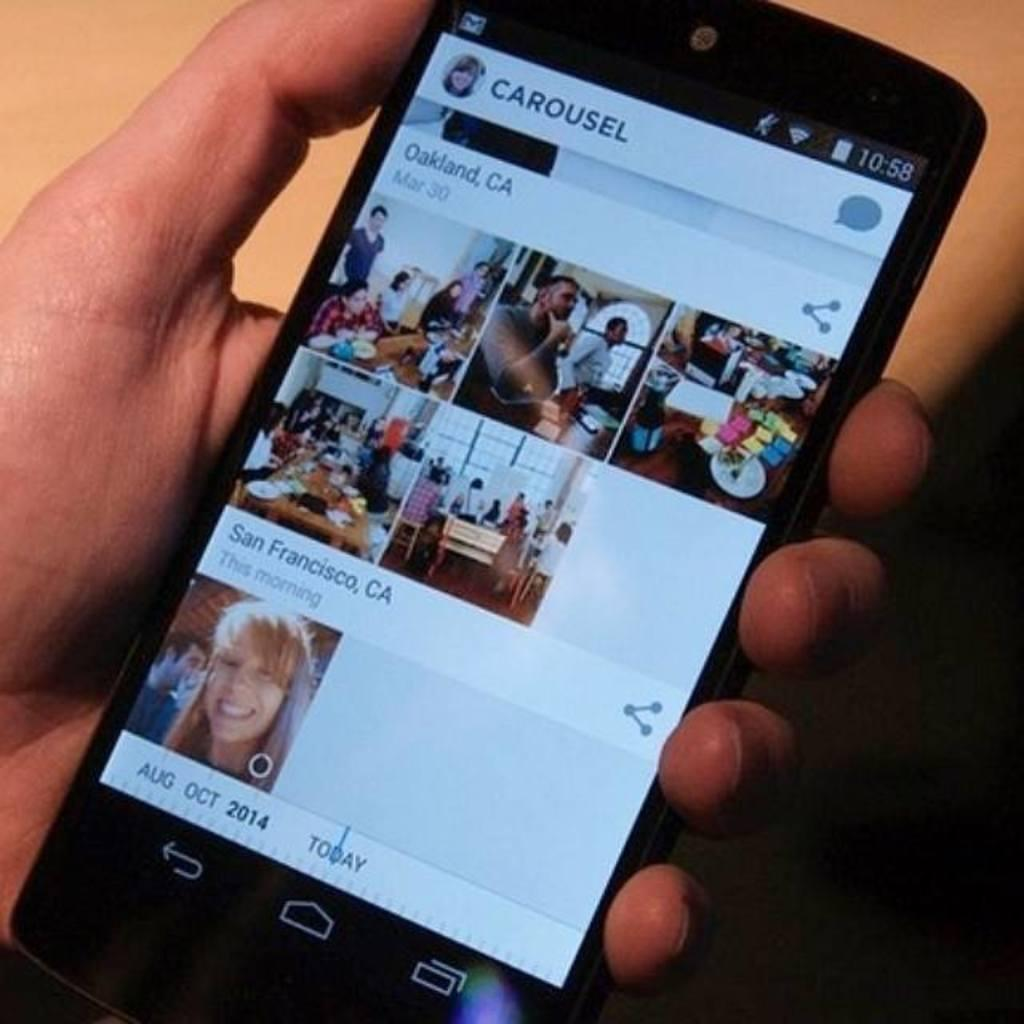What object is being held by a person in the image? There is a mobile phone in the image, and it is being held by a person. What type of club can be seen in the image? There is no club present in the image; it features a mobile phone being held by a person. What kind of loaf is being used to prop up the mobile phone in the image? There is no loaf present in the image, and the mobile phone is being held by a person, not propped up. 